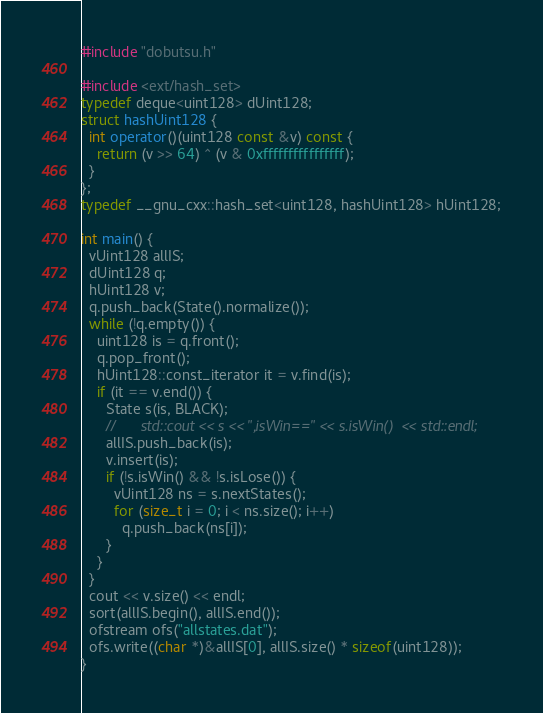Convert code to text. <code><loc_0><loc_0><loc_500><loc_500><_C++_>#include "dobutsu.h"

#include <ext/hash_set>
typedef deque<uint128> dUint128;
struct hashUint128 {
  int operator()(uint128 const &v) const {
    return (v >> 64) ^ (v & 0xffffffffffffffff);
  }
};
typedef __gnu_cxx::hash_set<uint128, hashUint128> hUint128;

int main() {
  vUint128 allIS;
  dUint128 q;
  hUint128 v;
  q.push_back(State().normalize());
  while (!q.empty()) {
    uint128 is = q.front();
    q.pop_front();
    hUint128::const_iterator it = v.find(is);
    if (it == v.end()) {
      State s(is, BLACK);
      //      std::cout << s << ",isWin==" << s.isWin()  << std::endl;
      allIS.push_back(is);
      v.insert(is);
      if (!s.isWin() && !s.isLose()) {
        vUint128 ns = s.nextStates();
        for (size_t i = 0; i < ns.size(); i++)
          q.push_back(ns[i]);
      }
    }
  }
  cout << v.size() << endl;
  sort(allIS.begin(), allIS.end());
  ofstream ofs("allstates.dat");
  ofs.write((char *)&allIS[0], allIS.size() * sizeof(uint128));
}
</code> 